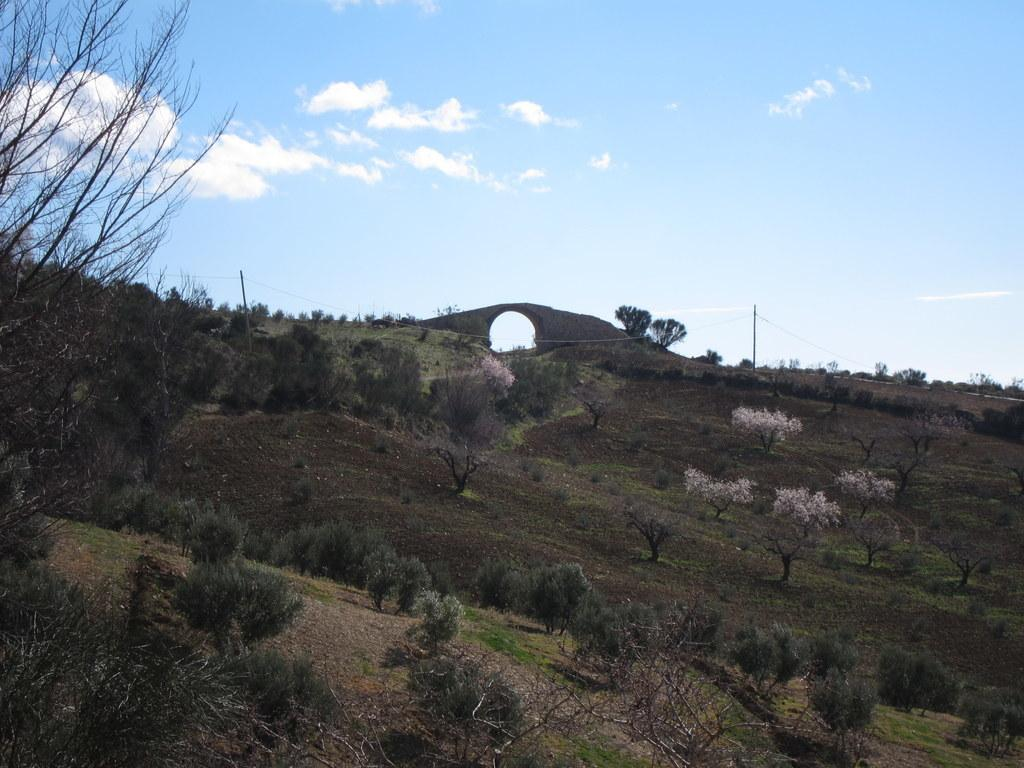What type of vegetation can be seen in the image? There are trees in the image. What is the color of the trees? The trees are green in color. What else can be seen in the background of the image? There are poles visible in the background of the image. How would you describe the sky in the image? The sky is a combination of white and blue colors. Can you tell me where the church is located in the image? There is no church present in the image. What type of seashore can be seen in the image? There is no seashore present in the image; it features trees, poles, and a sky with white and blue colors. 